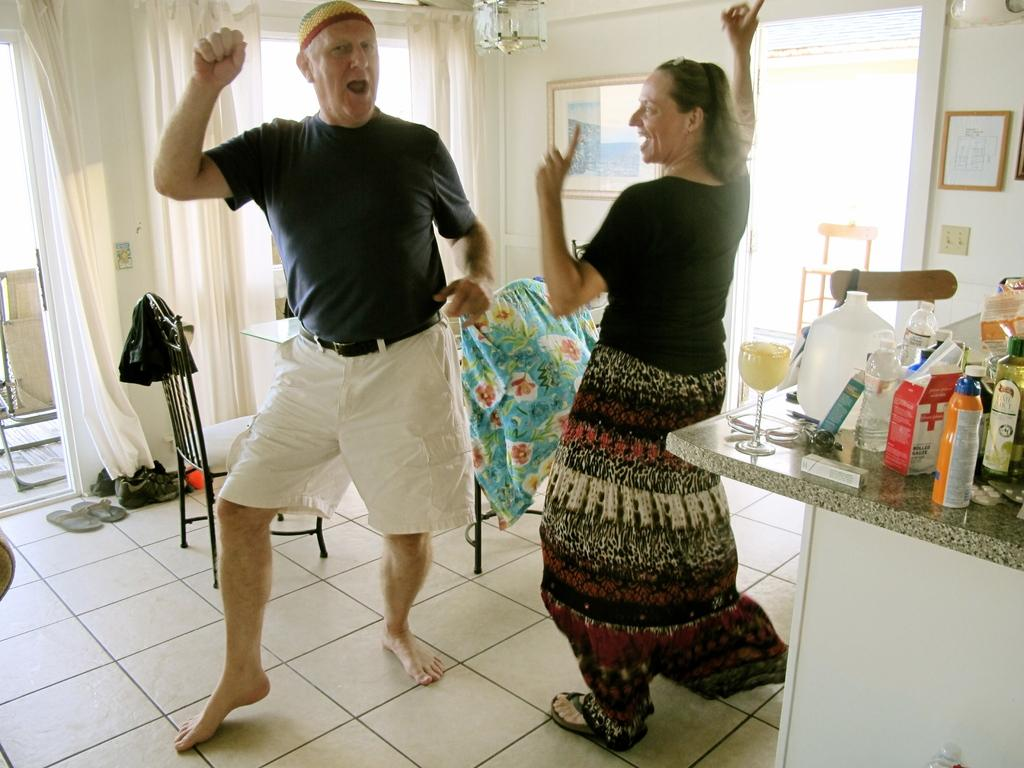How many people are in the image? There are two people in the image. What are the people doing in the image? The people are dancing on the floor. What is the color of the room in the image? The room is white. What can be seen on the right side of the image? There is a platform on the right side of the image. What is placed on the platform? Many bottles are kept on the platform. Can you tell me where the zoo is located in the image? There is no zoo present in the image. What type of kitty is sitting on the platform with the bottles? There is no kitty present in the image; only bottles are placed on the platform. 